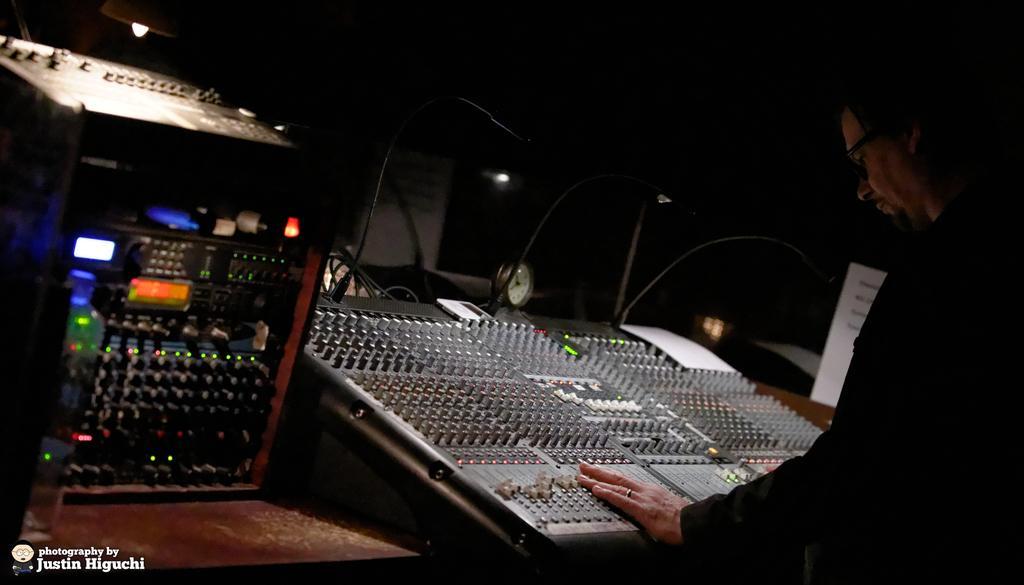Describe this image in one or two sentences. In this image there is a person operating an electronic device in front of him, beside the device there is another electronic device. 